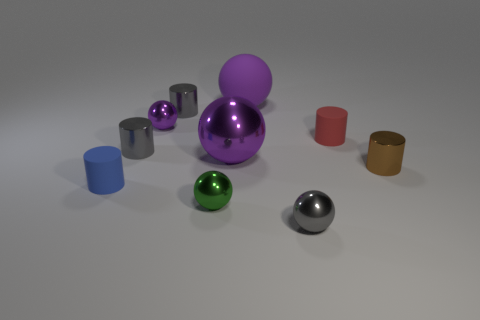Subtract all purple balls. How many were subtracted if there are1purple balls left? 2 Subtract all cyan cylinders. How many purple balls are left? 3 Subtract 1 cylinders. How many cylinders are left? 4 Subtract all brown cylinders. How many cylinders are left? 4 Subtract all green spheres. How many spheres are left? 4 Subtract all green cylinders. Subtract all blue spheres. How many cylinders are left? 5 Add 4 gray metallic objects. How many gray metallic objects are left? 7 Add 6 red rubber spheres. How many red rubber spheres exist? 6 Subtract 0 brown blocks. How many objects are left? 10 Subtract all small gray rubber spheres. Subtract all green balls. How many objects are left? 9 